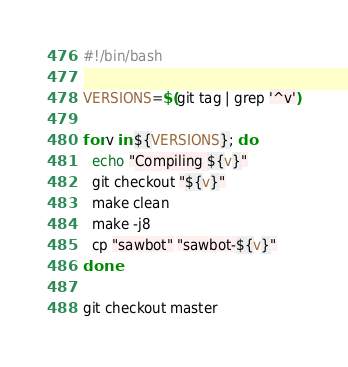<code> <loc_0><loc_0><loc_500><loc_500><_Bash_>#!/bin/bash

VERSIONS=$(git tag | grep '^v')

for v in ${VERSIONS}; do
  echo "Compiling ${v}"
  git checkout "${v}"
  make clean
  make -j8
  cp "sawbot" "sawbot-${v}"
done

git checkout master
</code> 